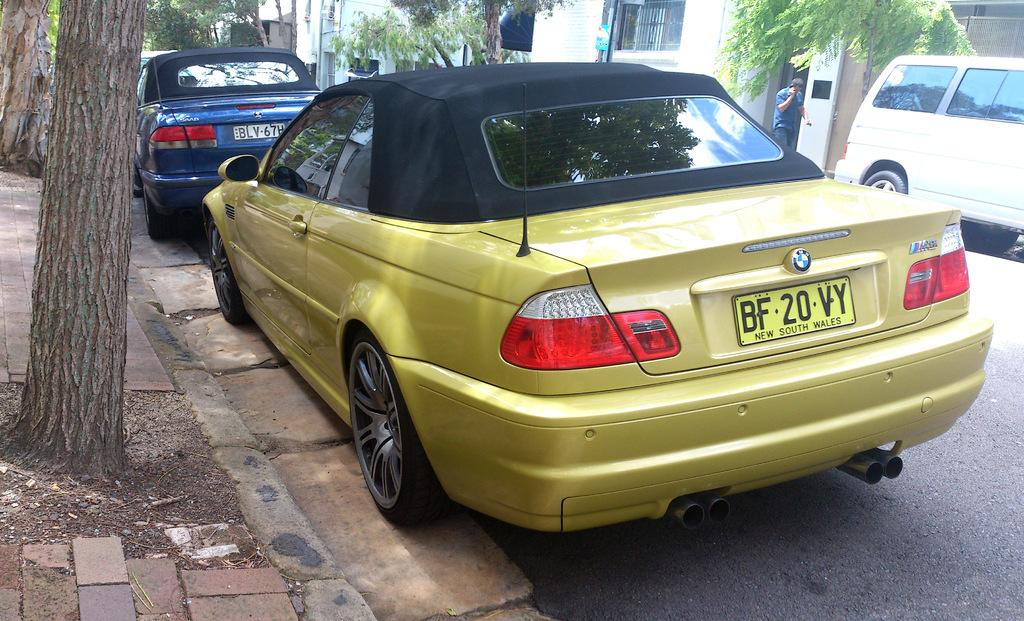What is happening on the road in the image? There are vehicles on the road in the image. Can you describe the background of the image? There are trees and buildings in the background of the image. Is there is a person visible in the image? Yes, there is a person visible in the background of the image. Where is the harbor located in the image? There is no harbor present in the image. How many geese are flying in the front of the image? There are no geese present in the image. 